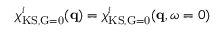Convert formula to latex. <formula><loc_0><loc_0><loc_500><loc_500>\chi _ { K S , \vec { G } = 0 } ^ { i } ( q ) = \chi _ { K S , \vec { G } = 0 } ^ { i } ( q , \omega = 0 )</formula> 